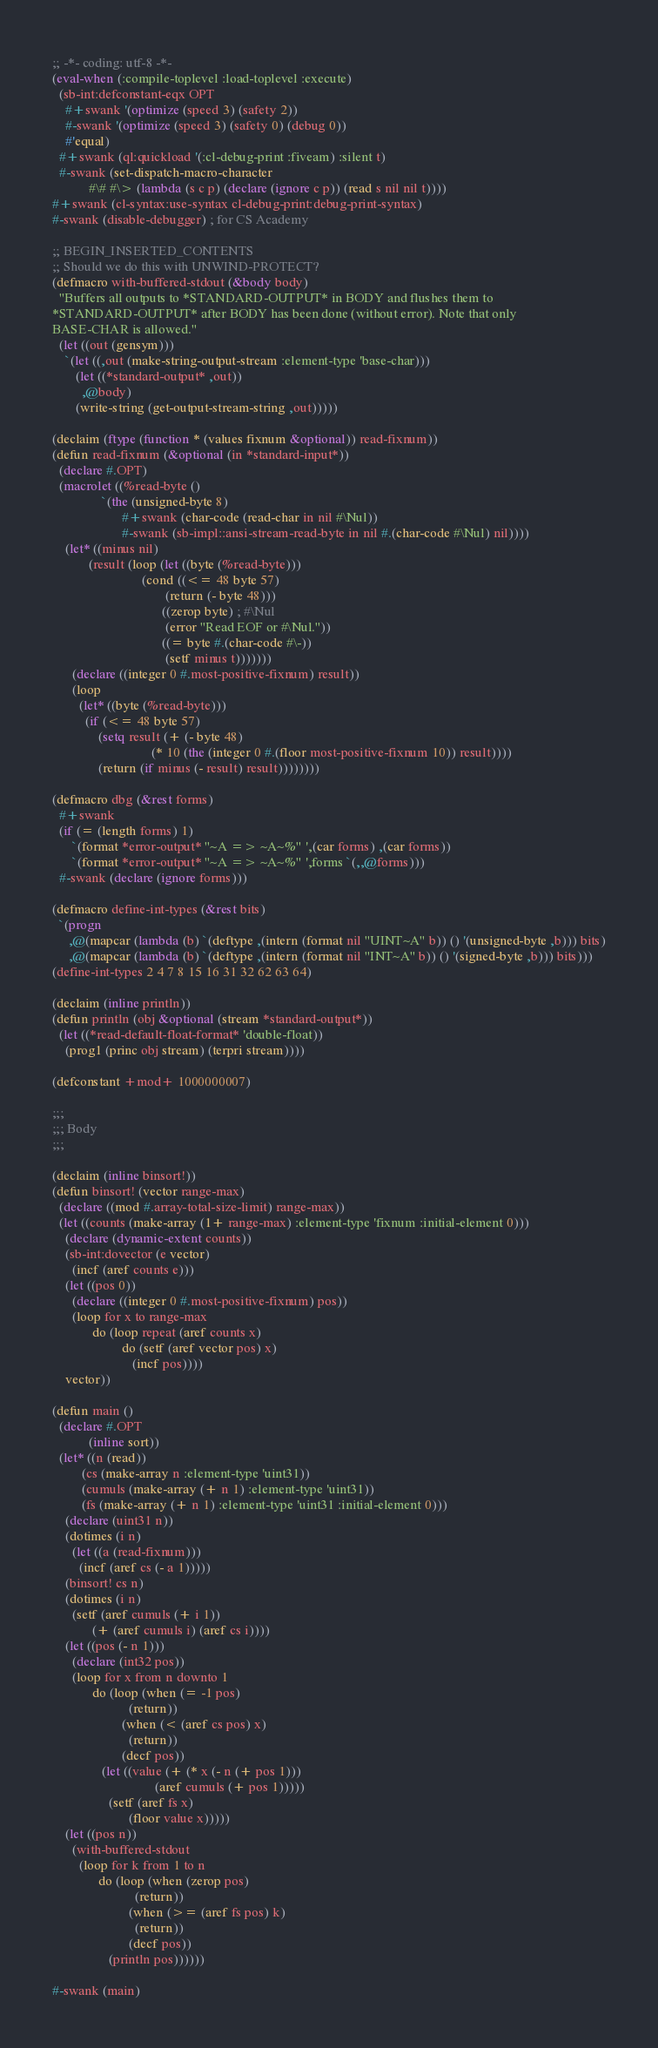<code> <loc_0><loc_0><loc_500><loc_500><_Lisp_>;; -*- coding: utf-8 -*-
(eval-when (:compile-toplevel :load-toplevel :execute)
  (sb-int:defconstant-eqx OPT
    #+swank '(optimize (speed 3) (safety 2))
    #-swank '(optimize (speed 3) (safety 0) (debug 0))
    #'equal)
  #+swank (ql:quickload '(:cl-debug-print :fiveam) :silent t)
  #-swank (set-dispatch-macro-character
           #\# #\> (lambda (s c p) (declare (ignore c p)) (read s nil nil t))))
#+swank (cl-syntax:use-syntax cl-debug-print:debug-print-syntax)
#-swank (disable-debugger) ; for CS Academy

;; BEGIN_INSERTED_CONTENTS
;; Should we do this with UNWIND-PROTECT?
(defmacro with-buffered-stdout (&body body)
  "Buffers all outputs to *STANDARD-OUTPUT* in BODY and flushes them to
*STANDARD-OUTPUT* after BODY has been done (without error). Note that only
BASE-CHAR is allowed."
  (let ((out (gensym)))
    `(let ((,out (make-string-output-stream :element-type 'base-char)))
       (let ((*standard-output* ,out))
         ,@body)
       (write-string (get-output-stream-string ,out)))))

(declaim (ftype (function * (values fixnum &optional)) read-fixnum))
(defun read-fixnum (&optional (in *standard-input*))
  (declare #.OPT)
  (macrolet ((%read-byte ()
               `(the (unsigned-byte 8)
                     #+swank (char-code (read-char in nil #\Nul))
                     #-swank (sb-impl::ansi-stream-read-byte in nil #.(char-code #\Nul) nil))))
    (let* ((minus nil)
           (result (loop (let ((byte (%read-byte)))
                           (cond ((<= 48 byte 57)
                                  (return (- byte 48)))
                                 ((zerop byte) ; #\Nul
                                  (error "Read EOF or #\Nul."))
                                 ((= byte #.(char-code #\-))
                                  (setf minus t)))))))
      (declare ((integer 0 #.most-positive-fixnum) result))
      (loop
        (let* ((byte (%read-byte)))
          (if (<= 48 byte 57)
              (setq result (+ (- byte 48)
                              (* 10 (the (integer 0 #.(floor most-positive-fixnum 10)) result))))
              (return (if minus (- result) result))))))))

(defmacro dbg (&rest forms)
  #+swank
  (if (= (length forms) 1)
      `(format *error-output* "~A => ~A~%" ',(car forms) ,(car forms))
      `(format *error-output* "~A => ~A~%" ',forms `(,,@forms)))
  #-swank (declare (ignore forms)))

(defmacro define-int-types (&rest bits)
  `(progn
     ,@(mapcar (lambda (b) `(deftype ,(intern (format nil "UINT~A" b)) () '(unsigned-byte ,b))) bits)
     ,@(mapcar (lambda (b) `(deftype ,(intern (format nil "INT~A" b)) () '(signed-byte ,b))) bits)))
(define-int-types 2 4 7 8 15 16 31 32 62 63 64)

(declaim (inline println))
(defun println (obj &optional (stream *standard-output*))
  (let ((*read-default-float-format* 'double-float))
    (prog1 (princ obj stream) (terpri stream))))

(defconstant +mod+ 1000000007)

;;;
;;; Body
;;;

(declaim (inline binsort!))
(defun binsort! (vector range-max)
  (declare ((mod #.array-total-size-limit) range-max))
  (let ((counts (make-array (1+ range-max) :element-type 'fixnum :initial-element 0)))
    (declare (dynamic-extent counts))
    (sb-int:dovector (e vector)
      (incf (aref counts e)))
    (let ((pos 0))
      (declare ((integer 0 #.most-positive-fixnum) pos))
      (loop for x to range-max
            do (loop repeat (aref counts x)
                     do (setf (aref vector pos) x)
                        (incf pos))))
    vector))

(defun main ()
  (declare #.OPT
           (inline sort))
  (let* ((n (read))
         (cs (make-array n :element-type 'uint31))
         (cumuls (make-array (+ n 1) :element-type 'uint31))
         (fs (make-array (+ n 1) :element-type 'uint31 :initial-element 0)))
    (declare (uint31 n))
    (dotimes (i n)
      (let ((a (read-fixnum)))
        (incf (aref cs (- a 1)))))
    (binsort! cs n)
    (dotimes (i n)
      (setf (aref cumuls (+ i 1))
            (+ (aref cumuls i) (aref cs i))))
    (let ((pos (- n 1)))
      (declare (int32 pos))
      (loop for x from n downto 1
            do (loop (when (= -1 pos)
                       (return))
                     (when (< (aref cs pos) x)
                       (return))
                     (decf pos))
               (let ((value (+ (* x (- n (+ pos 1)))
                               (aref cumuls (+ pos 1)))))
                 (setf (aref fs x)
                       (floor value x)))))
    (let ((pos n))
      (with-buffered-stdout
        (loop for k from 1 to n
              do (loop (when (zerop pos)
                         (return))
                       (when (>= (aref fs pos) k)
                         (return))
                       (decf pos))
                 (println pos))))))

#-swank (main)
</code> 